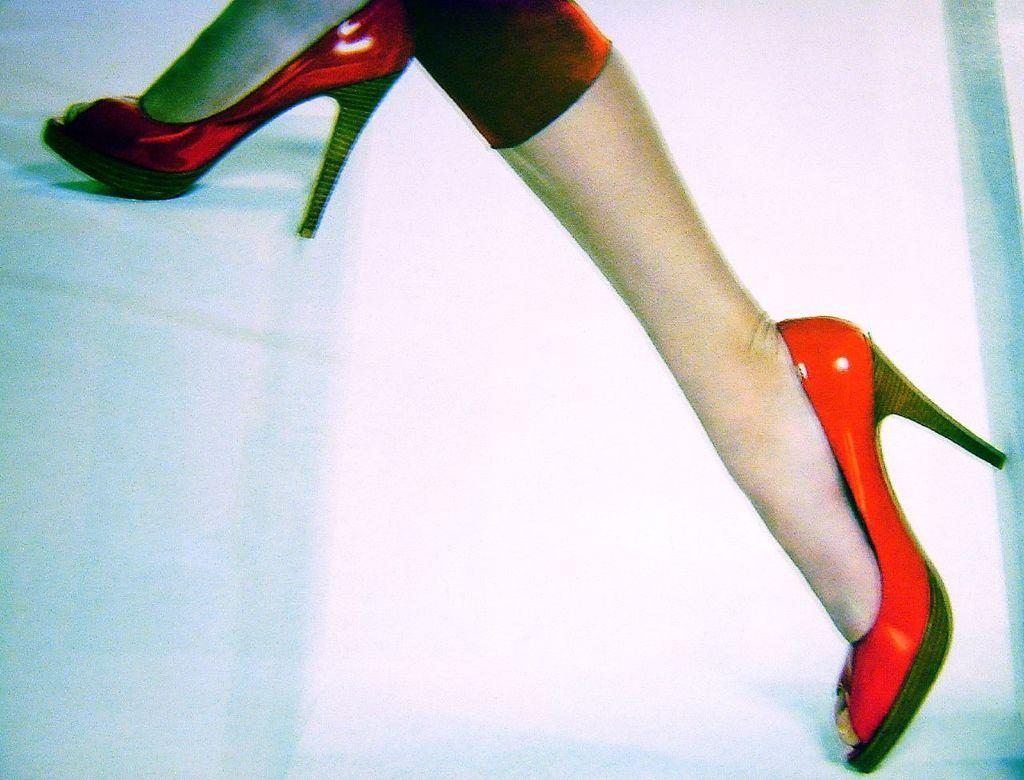Who or what is present in the image? There is a person in the image. What part of the person's body can be seen? The person's legs are visible. What color are the person's footwear? The person is wearing red color footwear. What is the color of the surface the person is walking on? The person is walking on a white color surface. What type of ornament is the person holding in the image? There is no ornament present in the image. Can you tell me what request the person is making in the image? There is no indication of a request being made in the image. 